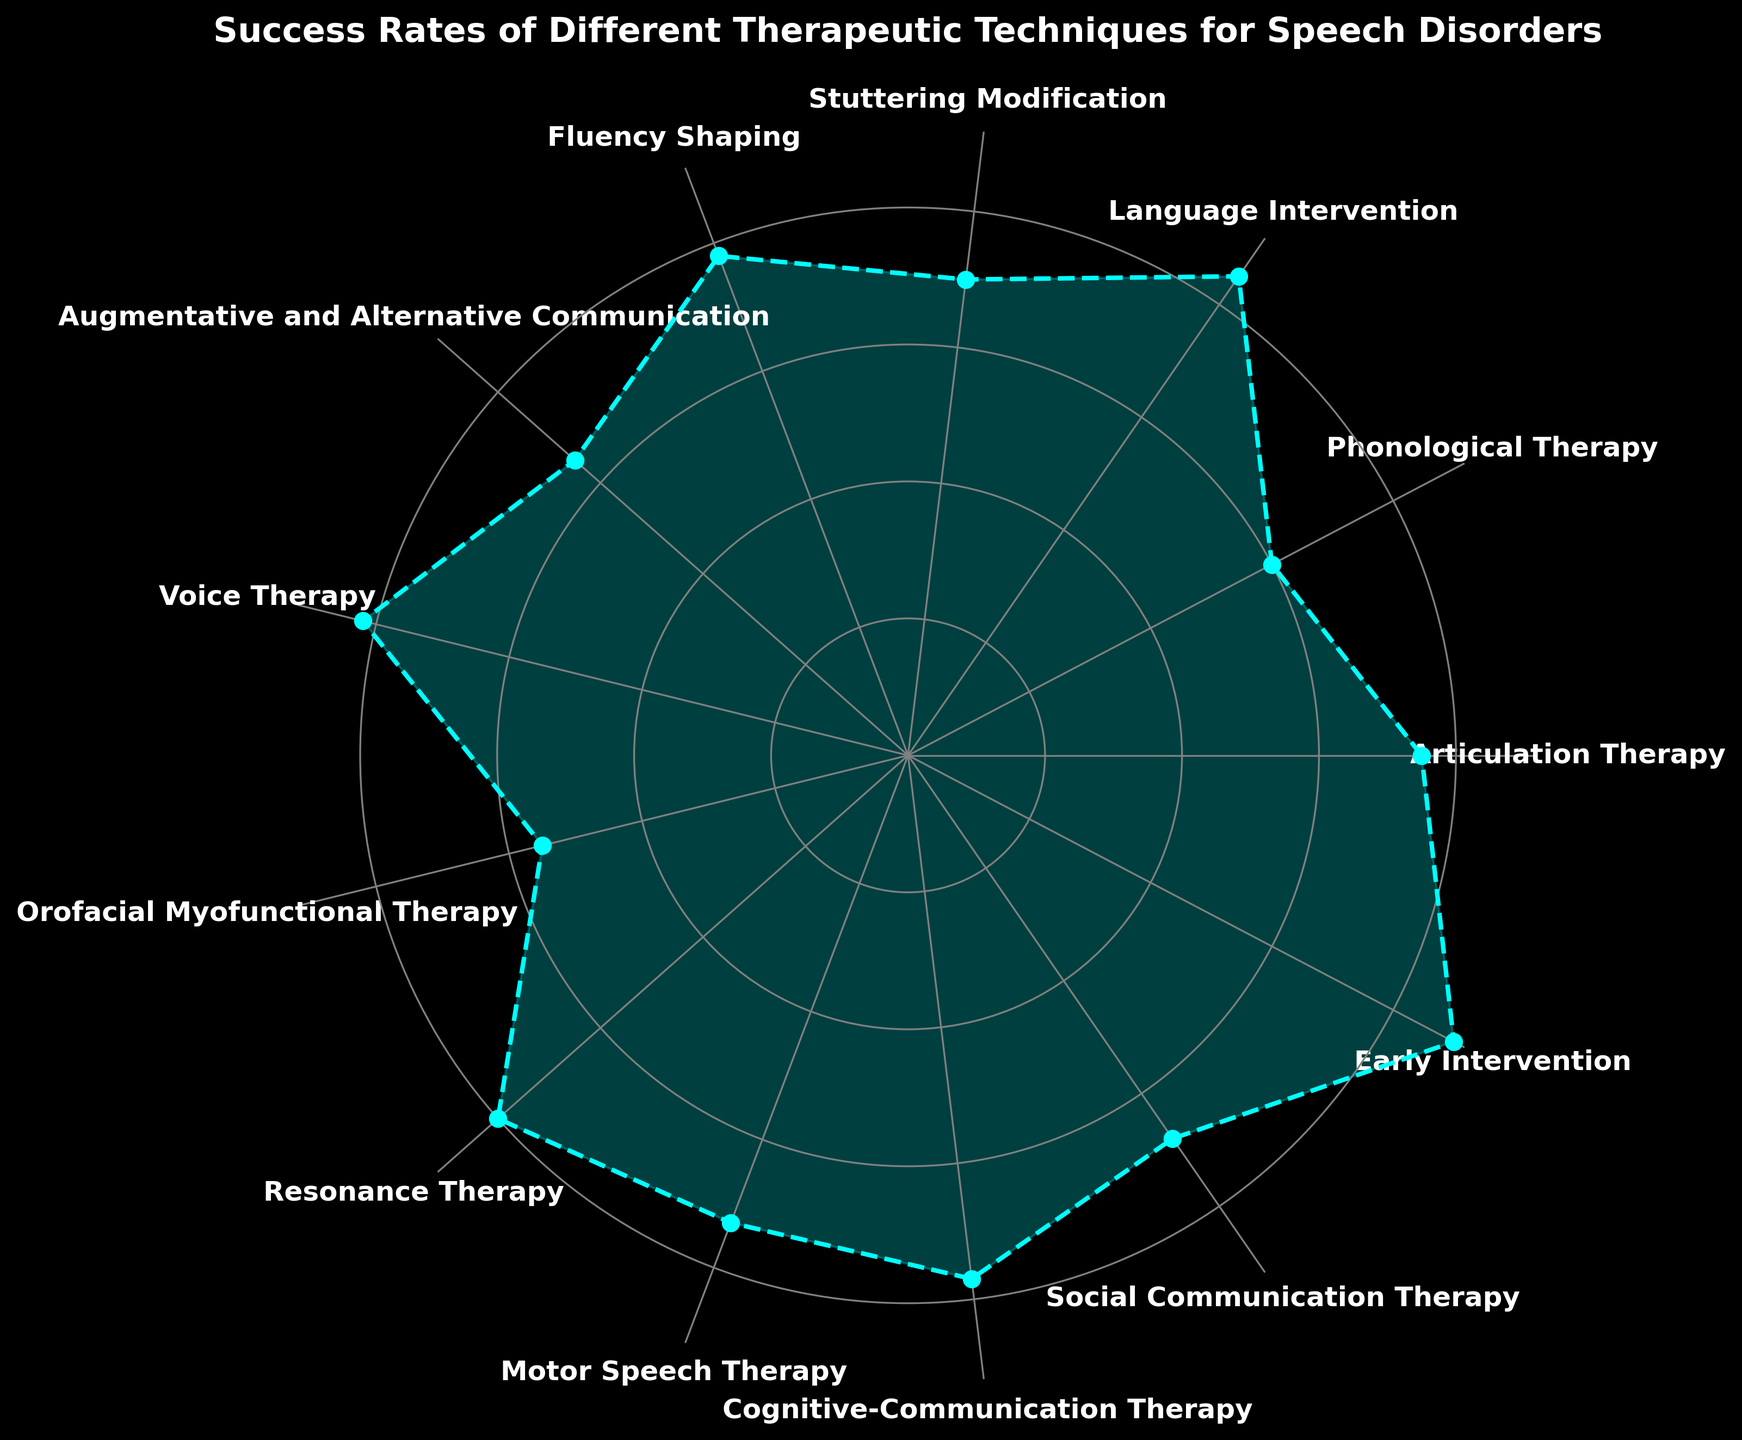What's the therapeutic technique with the highest success rate? By visually inspecting the figure, we can identify the technique that corresponds to the longest segment on the plot. This segment is labeled "Early Intervention."
Answer: Early Intervention Which therapeutic techniques have success rates above 80%? The figure shows the success rates of each technique on a polar coordinate system. The segments for "Language Intervention," "Voice Therapy," "Resonance Therapy," and "Early Intervention" are above 80%.
Answer: Language Intervention, Voice Therapy, Resonance Therapy, Early Intervention What is the difference in success rates between Articulation Therapy and Orofacial Myofunctional Therapy? By checking the lengths of the segments for Articulation Therapy (75%) and Orofacial Myofunctional Therapy (55%), we subtract the latter from the former (75 - 55).
Answer: 20% How many techniques have a success rate lower than 70%? Looking at the figure, we identify the techniques with success rates below 70%. These are "Phonological Therapy," "Augmentative and Alternative Communication," and "Orofacial Myofunctional Therapy," totaling three techniques.
Answer: 3 What is the average success rate of the top four techniques? First, we identify the top four techniques by their success rates: Early Intervention (90%), Language Intervention (85%), Voice Therapy (82%), and Resonance Therapy (80%). We then calculate the average: (90 + 85 + 82 + 80) / 4.
Answer: 84.25 Which technique is positioned directly opposite to Voice Therapy? Observing the circular nature of the plot, "Voice Therapy" is visually opposite to "Orofacial Myofunctional Therapy."
Answer: Orofacial Myofunctional Therapy What is the median success rate of all techniques? We list all success rates in ascending order: 55, 60, 65, 68, 70, 73, 75, 77, 78, 80, 82, 85, 90. The middle value (7th in the list) is 75, the median success rate.
Answer: 75 Which technique has a success rate closest to the midpoint between the highest and the lowest success rates? The highest rate is 90% (Early Intervention), and the lowest is 55% (Orofacial Myofunctional Therapy). The midpoint is (90 + 55) / 2 = 72.5. The closest success rate is 73% for Motor Speech Therapy.
Answer: Motor Speech Therapy How many techniques fall within a 10% success rate range of Fluency Shaping? Fluency Shaping has a success rate of 78%. Techniques within 10% of that range (68% to 88%) are: Phonological Therapy, Stuttering Modification, Voice Therapy, Resonance Therapy, Motor Speech Therapy, Cognitive-Communication Therapy, and Social Communication Therapy, totaling seven techniques.
Answer: 7 Which technique(s) have success rates within 5% of Articulation Therapy? Articulation Therapy has a success rate of 75%. Techniques within 5% of that (70% to 80%) are: Stuttering Modification, and Motor Speech Therapy.
Answer: Stuttering Modification, Motor Speech Therapy 